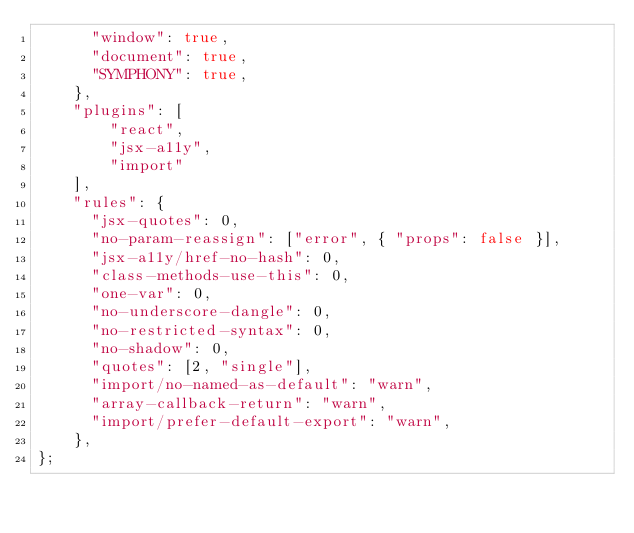Convert code to text. <code><loc_0><loc_0><loc_500><loc_500><_JavaScript_>      "window": true,
      "document": true,
      "SYMPHONY": true,
    },
    "plugins": [
        "react",
        "jsx-a11y",
        "import"
    ],
    "rules": {
      "jsx-quotes": 0,
      "no-param-reassign": ["error", { "props": false }],
      "jsx-a11y/href-no-hash": 0,
      "class-methods-use-this": 0,
      "one-var": 0,
      "no-underscore-dangle": 0,
      "no-restricted-syntax": 0,
      "no-shadow": 0,
      "quotes": [2, "single"],
      "import/no-named-as-default": "warn",
      "array-callback-return": "warn",
      "import/prefer-default-export": "warn",
    },
};</code> 